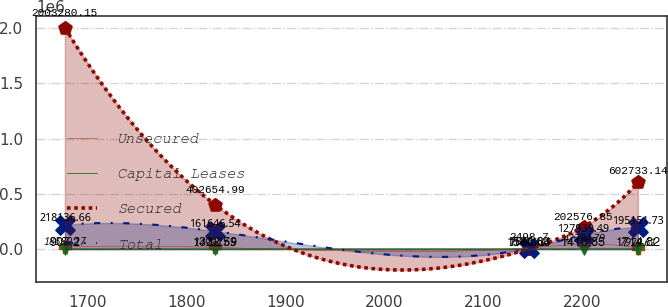<chart> <loc_0><loc_0><loc_500><loc_500><line_chart><ecel><fcel>Unsecured<fcel>Capital Leases<fcel>Secured<fcel>Total<nl><fcel>1676.69<fcel>18389.2<fcel>907.2<fcel>2.00328e+06<fcel>218137<nl><fcel>1828.67<fcel>14902.6<fcel>1332.59<fcel>402655<fcel>161647<nl><fcel>2146.86<fcel>11416.1<fcel>1560.64<fcel>2498.7<fcel>7666.69<nl><fcel>2201.91<fcel>42794.8<fcel>1413.35<fcel>202577<fcel>127939<nl><fcel>2256.96<fcel>7929.61<fcel>1714.82<fcel>602733<fcel>195152<nl></chart> 